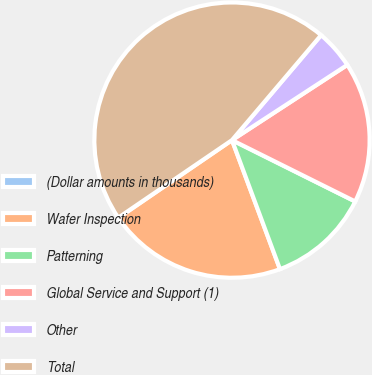Convert chart to OTSL. <chart><loc_0><loc_0><loc_500><loc_500><pie_chart><fcel>(Dollar amounts in thousands)<fcel>Wafer Inspection<fcel>Patterning<fcel>Global Service and Support (1)<fcel>Other<fcel>Total<nl><fcel>0.03%<fcel>21.11%<fcel>11.98%<fcel>16.55%<fcel>4.6%<fcel>45.73%<nl></chart> 